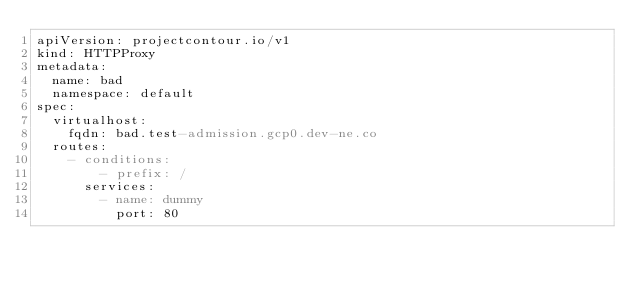<code> <loc_0><loc_0><loc_500><loc_500><_YAML_>apiVersion: projectcontour.io/v1
kind: HTTPProxy
metadata:
  name: bad
  namespace: default
spec:
  virtualhost:
    fqdn: bad.test-admission.gcp0.dev-ne.co
  routes:
    - conditions:
        - prefix: /
      services:
        - name: dummy
          port: 80
</code> 